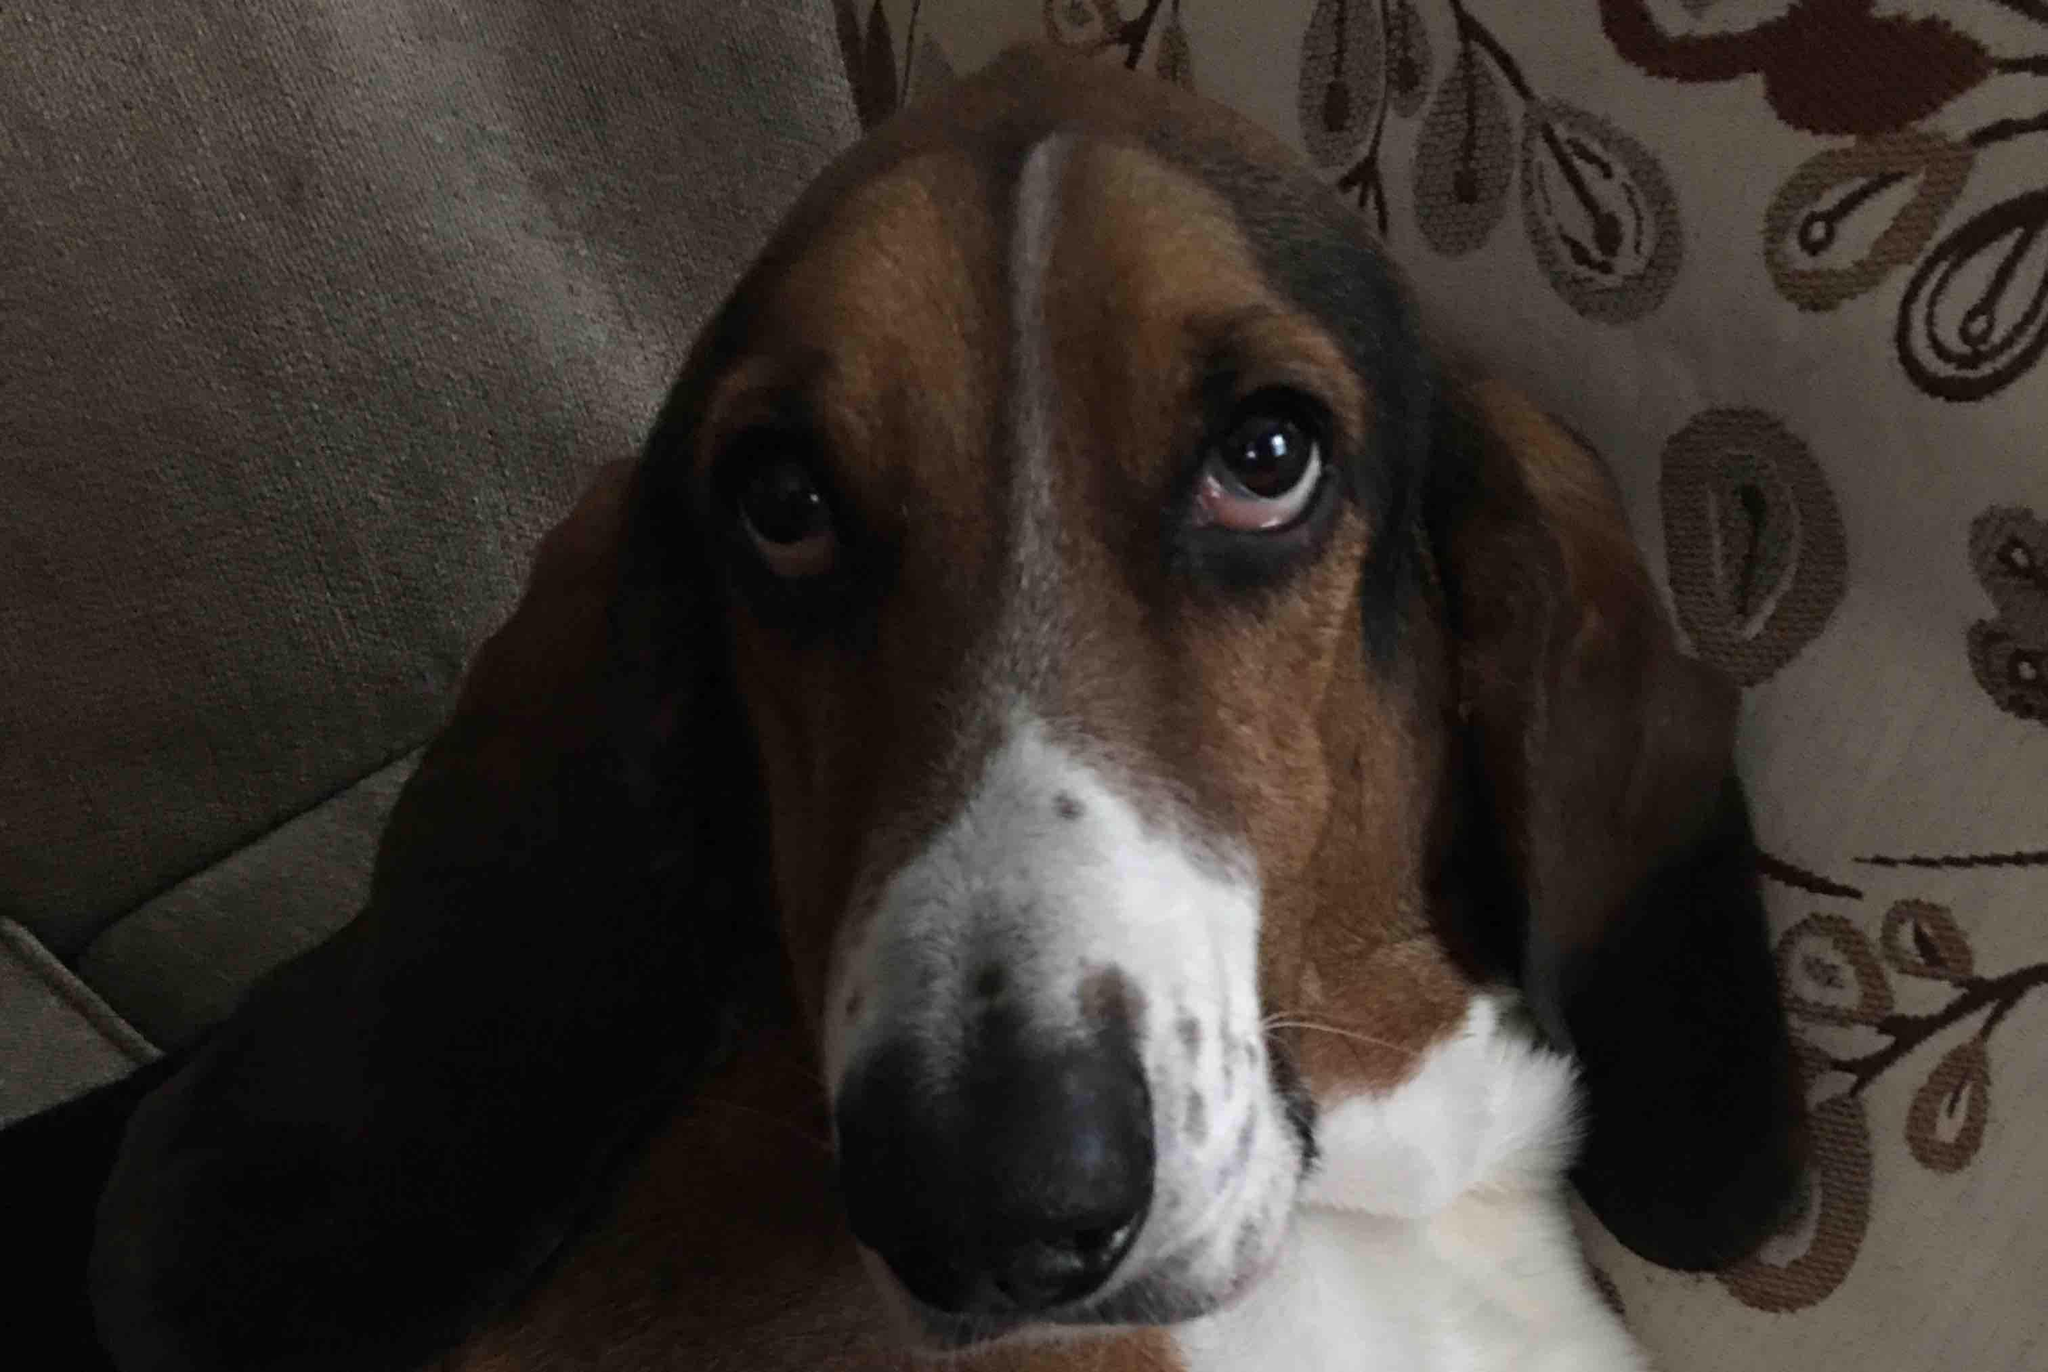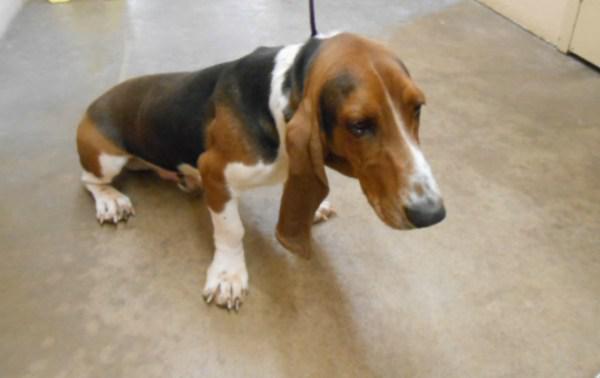The first image is the image on the left, the second image is the image on the right. For the images displayed, is the sentence "The rightmost image features a single basset hound, on a leash, with no face of a person visible." factually correct? Answer yes or no. Yes. The first image is the image on the left, the second image is the image on the right. Analyze the images presented: Is the assertion "The dog in the right image is being held on a leash." valid? Answer yes or no. Yes. 